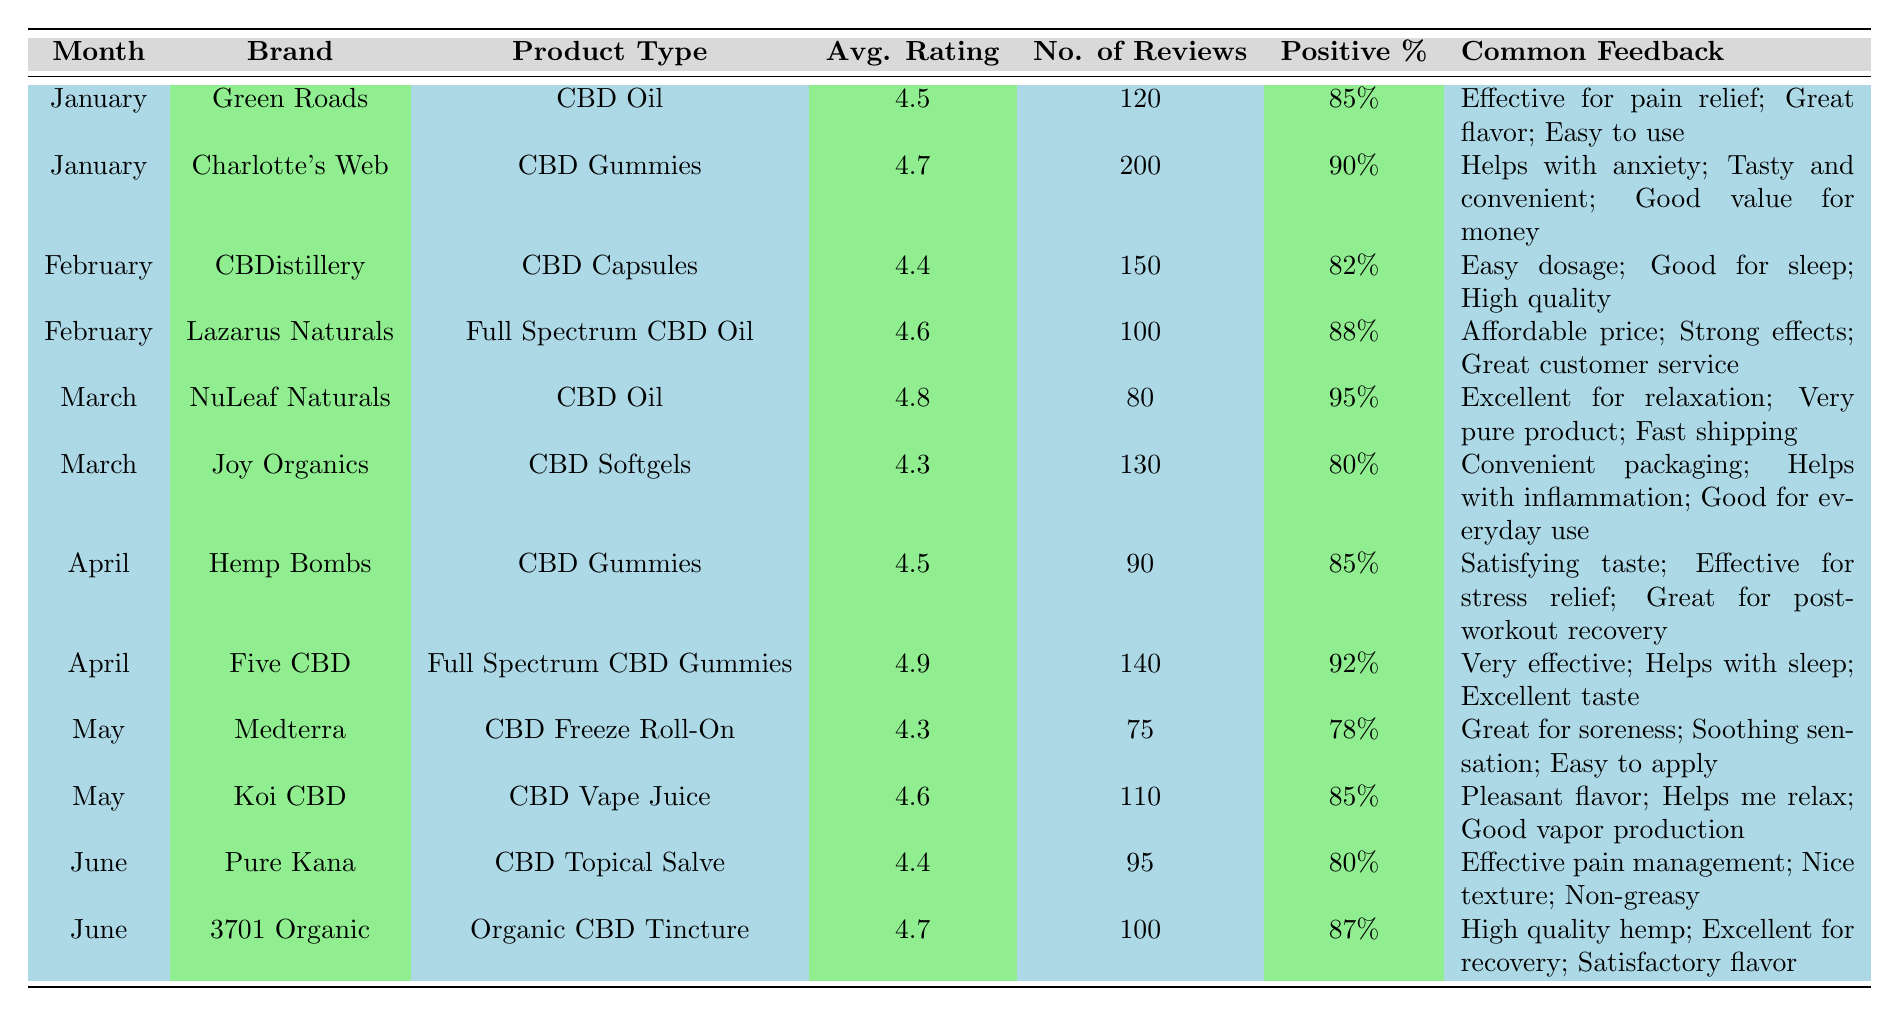What was the highest average rating achieved by any CBD product in January? The table shows that the highest average rating in January is 4.7 for Charlotte's Web CBD Gummies.
Answer: 4.7 Which product type received the most reviews in February? In February, Charlotte's Web CBD Gummies received 200 reviews. The second highest was CBD Capsules with 150 reviews, making Gummies the most reviewed product type that month.
Answer: CBD Gummies What percentage of positive feedback did the Five CBD product receive? The table lists Five CBD's positive feedback percentage as 92%.
Answer: 92% Which brand had the highest percentage of positive feedback in March? Among the brands listed for March, NuLeaf Naturals had a positive feedback percentage of 95%, the highest for that month.
Answer: NuLeaf Naturals What is the average rating for the products listed in April? April shows two products: Hemp Bombs at 4.5 and Five CBD at 4.9. The sum is 4.5 + 4.9 = 9.4, and the average rating is 9.4/2 = 4.7.
Answer: 4.7 Did all products listed have an average rating of 4.0 or higher? Yes, all products in the table have ratings above 4.0, confirming they are rated positively.
Answer: Yes Considering all months, which product type had the most consistent positive feedback percentages? By examining the percentages, CBD Oil has positive feedback percentages of 85% (Green Roads), 95% (NuLeaf Naturals), and does not drop below this, while other types do. Thus, CBD Oil shows the most consistency in positive feedback percentages.
Answer: CBD Oil What brand shows improvement in average rating from January to February? The average rating for Lazarus Naturals in February is 4.6 compared to Green Roads’ 4.5 in January. This shows improvement from January to February.
Answer: Lazarus Naturals How many products listed had average ratings below 4.5? The table indicates two products have average ratings below 4.5: Joy Organics with 4.3 and Medterra with 4.3.
Answer: 2 Which month had the highest overall positive feedback percentages among products listed? The highest positive feedback is observed in March with ratings of 80% for Joy Organics and 95% for NuLeaf Naturals, making it the month with the highest overall positive feedback percentages among products listed.
Answer: March 